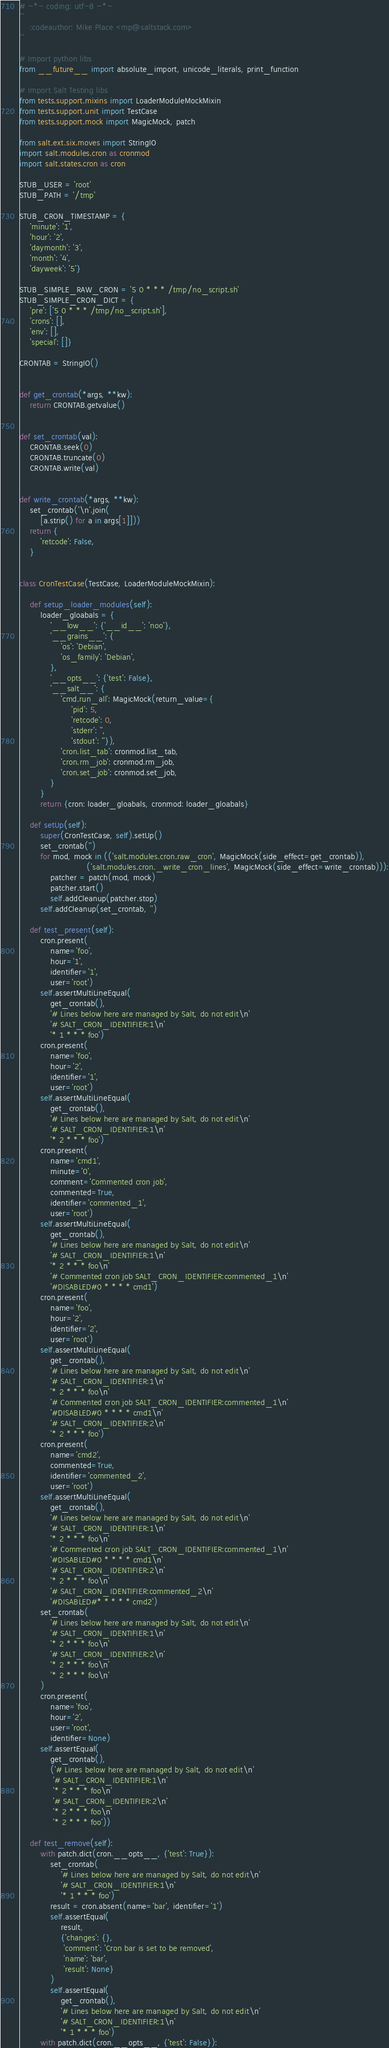<code> <loc_0><loc_0><loc_500><loc_500><_Python_># -*- coding: utf-8 -*-
'''
    :codeauthor: Mike Place <mp@saltstack.com>
'''

# Import python libs
from __future__ import absolute_import, unicode_literals, print_function

# Import Salt Testing libs
from tests.support.mixins import LoaderModuleMockMixin
from tests.support.unit import TestCase
from tests.support.mock import MagicMock, patch

from salt.ext.six.moves import StringIO
import salt.modules.cron as cronmod
import salt.states.cron as cron

STUB_USER = 'root'
STUB_PATH = '/tmp'

STUB_CRON_TIMESTAMP = {
    'minute': '1',
    'hour': '2',
    'daymonth': '3',
    'month': '4',
    'dayweek': '5'}

STUB_SIMPLE_RAW_CRON = '5 0 * * * /tmp/no_script.sh'
STUB_SIMPLE_CRON_DICT = {
    'pre': ['5 0 * * * /tmp/no_script.sh'],
    'crons': [],
    'env': [],
    'special': []}

CRONTAB = StringIO()


def get_crontab(*args, **kw):
    return CRONTAB.getvalue()


def set_crontab(val):
    CRONTAB.seek(0)
    CRONTAB.truncate(0)
    CRONTAB.write(val)


def write_crontab(*args, **kw):
    set_crontab('\n'.join(
        [a.strip() for a in args[1]]))
    return {
        'retcode': False,
    }


class CronTestCase(TestCase, LoaderModuleMockMixin):

    def setup_loader_modules(self):
        loader_gloabals = {
            '__low__': {'__id__': 'noo'},
            '__grains__': {
                'os': 'Debian',
                'os_family': 'Debian',
            },
            '__opts__': {'test': False},
            '__salt__': {
                'cmd.run_all': MagicMock(return_value={
                    'pid': 5,
                    'retcode': 0,
                    'stderr': '',
                    'stdout': ''}),
                'cron.list_tab': cronmod.list_tab,
                'cron.rm_job': cronmod.rm_job,
                'cron.set_job': cronmod.set_job,
            }
        }
        return {cron: loader_gloabals, cronmod: loader_gloabals}

    def setUp(self):
        super(CronTestCase, self).setUp()
        set_crontab('')
        for mod, mock in (('salt.modules.cron.raw_cron', MagicMock(side_effect=get_crontab)),
                          ('salt.modules.cron._write_cron_lines', MagicMock(side_effect=write_crontab))):
            patcher = patch(mod, mock)
            patcher.start()
            self.addCleanup(patcher.stop)
        self.addCleanup(set_crontab, '')

    def test_present(self):
        cron.present(
            name='foo',
            hour='1',
            identifier='1',
            user='root')
        self.assertMultiLineEqual(
            get_crontab(),
            '# Lines below here are managed by Salt, do not edit\n'
            '# SALT_CRON_IDENTIFIER:1\n'
            '* 1 * * * foo')
        cron.present(
            name='foo',
            hour='2',
            identifier='1',
            user='root')
        self.assertMultiLineEqual(
            get_crontab(),
            '# Lines below here are managed by Salt, do not edit\n'
            '# SALT_CRON_IDENTIFIER:1\n'
            '* 2 * * * foo')
        cron.present(
            name='cmd1',
            minute='0',
            comment='Commented cron job',
            commented=True,
            identifier='commented_1',
            user='root')
        self.assertMultiLineEqual(
            get_crontab(),
            '# Lines below here are managed by Salt, do not edit\n'
            '# SALT_CRON_IDENTIFIER:1\n'
            '* 2 * * * foo\n'
            '# Commented cron job SALT_CRON_IDENTIFIER:commented_1\n'
            '#DISABLED#0 * * * * cmd1')
        cron.present(
            name='foo',
            hour='2',
            identifier='2',
            user='root')
        self.assertMultiLineEqual(
            get_crontab(),
            '# Lines below here are managed by Salt, do not edit\n'
            '# SALT_CRON_IDENTIFIER:1\n'
            '* 2 * * * foo\n'
            '# Commented cron job SALT_CRON_IDENTIFIER:commented_1\n'
            '#DISABLED#0 * * * * cmd1\n'
            '# SALT_CRON_IDENTIFIER:2\n'
            '* 2 * * * foo')
        cron.present(
            name='cmd2',
            commented=True,
            identifier='commented_2',
            user='root')
        self.assertMultiLineEqual(
            get_crontab(),
            '# Lines below here are managed by Salt, do not edit\n'
            '# SALT_CRON_IDENTIFIER:1\n'
            '* 2 * * * foo\n'
            '# Commented cron job SALT_CRON_IDENTIFIER:commented_1\n'
            '#DISABLED#0 * * * * cmd1\n'
            '# SALT_CRON_IDENTIFIER:2\n'
            '* 2 * * * foo\n'
            '# SALT_CRON_IDENTIFIER:commented_2\n'
            '#DISABLED#* * * * * cmd2')
        set_crontab(
            '# Lines below here are managed by Salt, do not edit\n'
            '# SALT_CRON_IDENTIFIER:1\n'
            '* 2 * * * foo\n'
            '# SALT_CRON_IDENTIFIER:2\n'
            '* 2 * * * foo\n'
            '* 2 * * * foo\n'
        )
        cron.present(
            name='foo',
            hour='2',
            user='root',
            identifier=None)
        self.assertEqual(
            get_crontab(),
            ('# Lines below here are managed by Salt, do not edit\n'
             '# SALT_CRON_IDENTIFIER:1\n'
             '* 2 * * * foo\n'
             '# SALT_CRON_IDENTIFIER:2\n'
             '* 2 * * * foo\n'
             '* 2 * * * foo'))

    def test_remove(self):
        with patch.dict(cron.__opts__, {'test': True}):
            set_crontab(
                '# Lines below here are managed by Salt, do not edit\n'
                '# SALT_CRON_IDENTIFIER:1\n'
                '* 1 * * * foo')
            result = cron.absent(name='bar', identifier='1')
            self.assertEqual(
                result,
                {'changes': {},
                 'comment': 'Cron bar is set to be removed',
                 'name': 'bar',
                 'result': None}
            )
            self.assertEqual(
                get_crontab(),
                '# Lines below here are managed by Salt, do not edit\n'
                '# SALT_CRON_IDENTIFIER:1\n'
                '* 1 * * * foo')
        with patch.dict(cron.__opts__, {'test': False}):</code> 